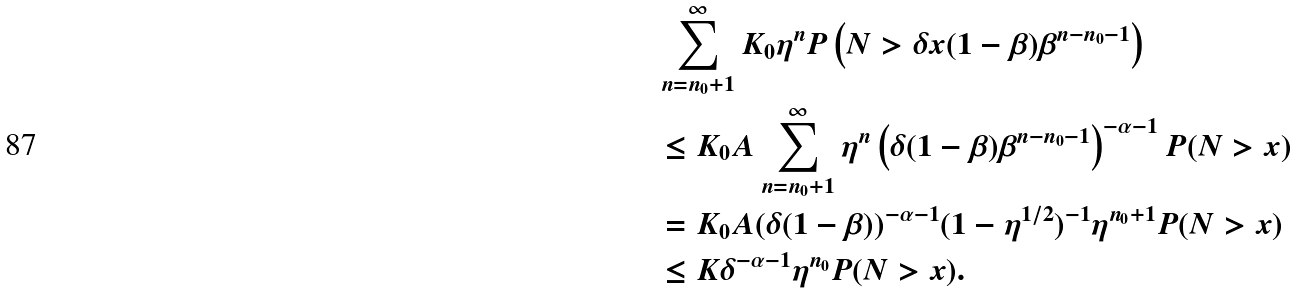<formula> <loc_0><loc_0><loc_500><loc_500>& \sum _ { n = n _ { 0 } + 1 } ^ { \infty } K _ { 0 } \eta ^ { n } P \left ( N > \delta x ( 1 - \beta ) \beta ^ { n - n _ { 0 } - 1 } \right ) \\ & \leq K _ { 0 } A \sum _ { n = n _ { 0 } + 1 } ^ { \infty } \eta ^ { n } \left ( \delta ( 1 - \beta ) \beta ^ { n - n _ { 0 } - 1 } \right ) ^ { - \alpha - 1 } P ( N > x ) \\ & = K _ { 0 } A ( \delta ( 1 - \beta ) ) ^ { - \alpha - 1 } ( 1 - \eta ^ { 1 / 2 } ) ^ { - 1 } \eta ^ { n _ { 0 } + 1 } P ( N > x ) \\ & \leq K \delta ^ { - \alpha - 1 } \eta ^ { n _ { 0 } } P ( N > x ) .</formula> 